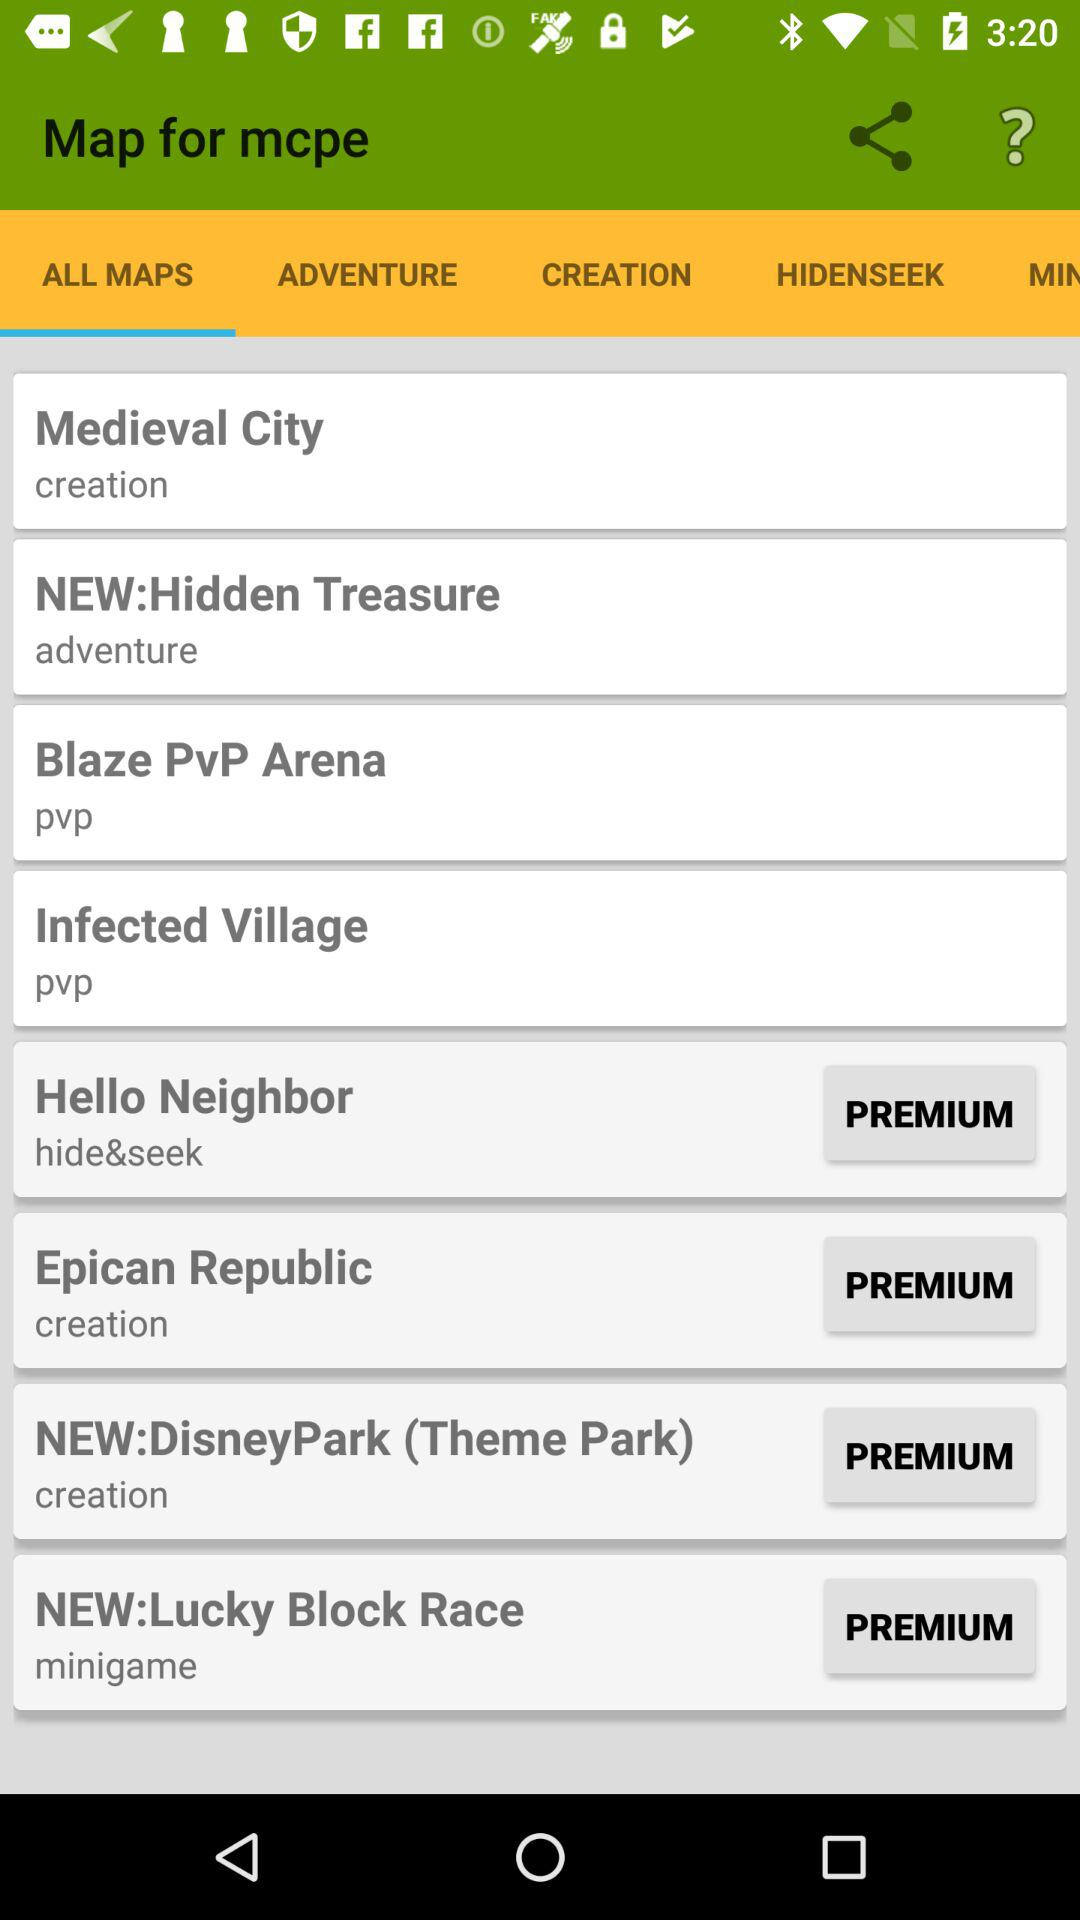Which option is selected? The selected option is "ALL MAPS". 